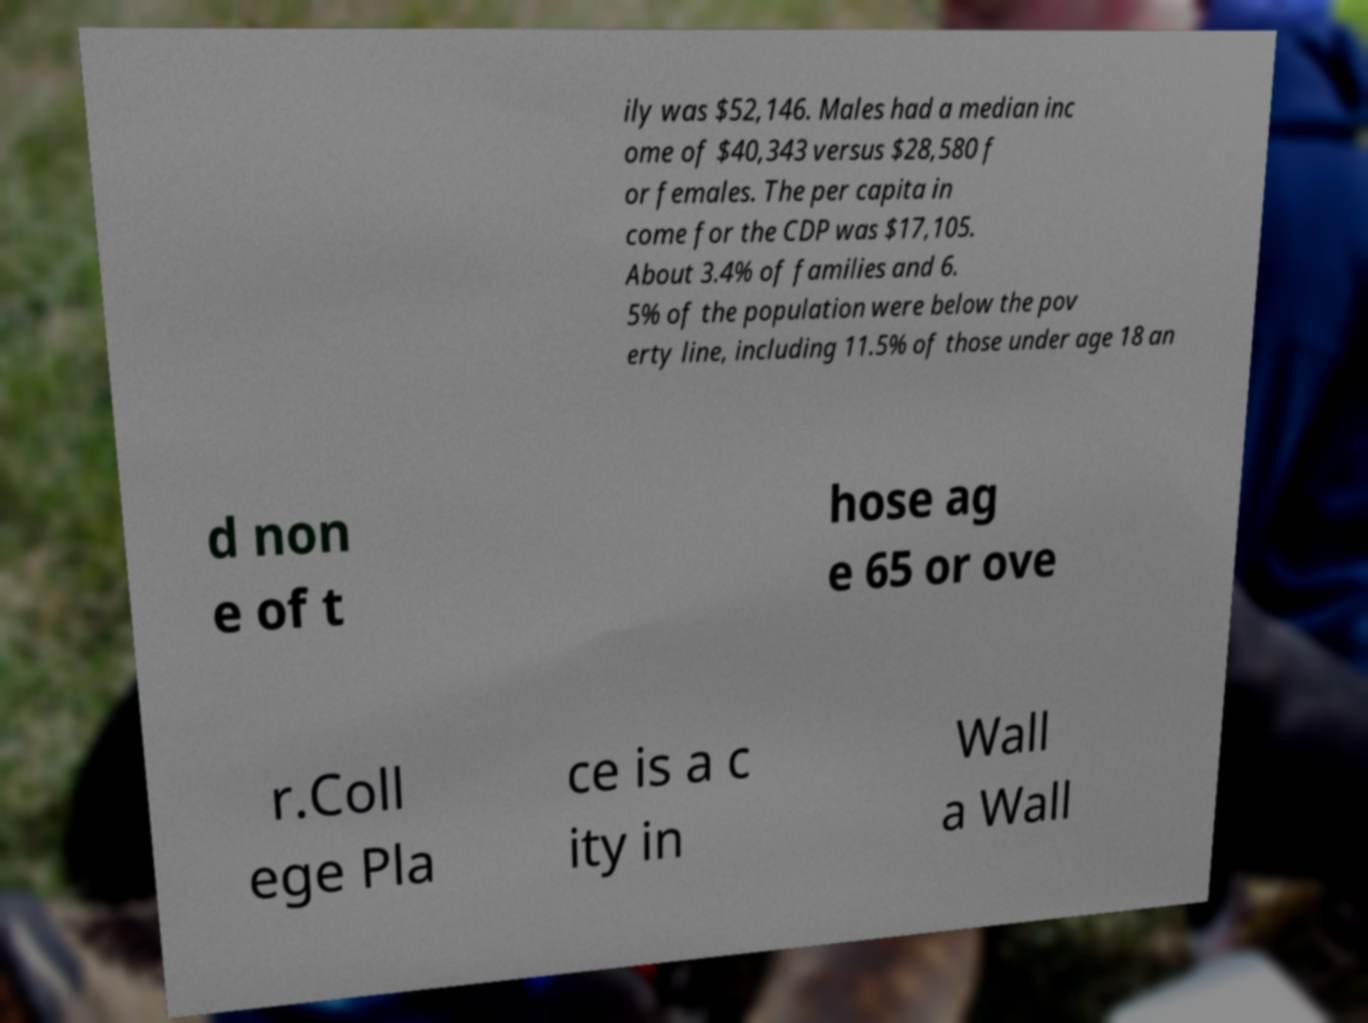For documentation purposes, I need the text within this image transcribed. Could you provide that? ily was $52,146. Males had a median inc ome of $40,343 versus $28,580 f or females. The per capita in come for the CDP was $17,105. About 3.4% of families and 6. 5% of the population were below the pov erty line, including 11.5% of those under age 18 an d non e of t hose ag e 65 or ove r.Coll ege Pla ce is a c ity in Wall a Wall 